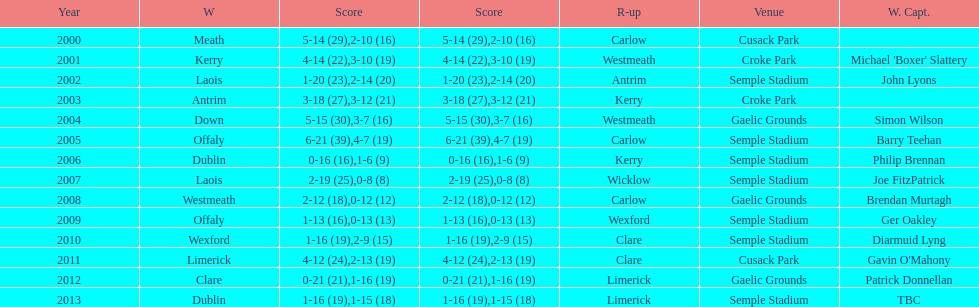Who was the winning captain the last time the competition was held at the gaelic grounds venue? Patrick Donnellan. 